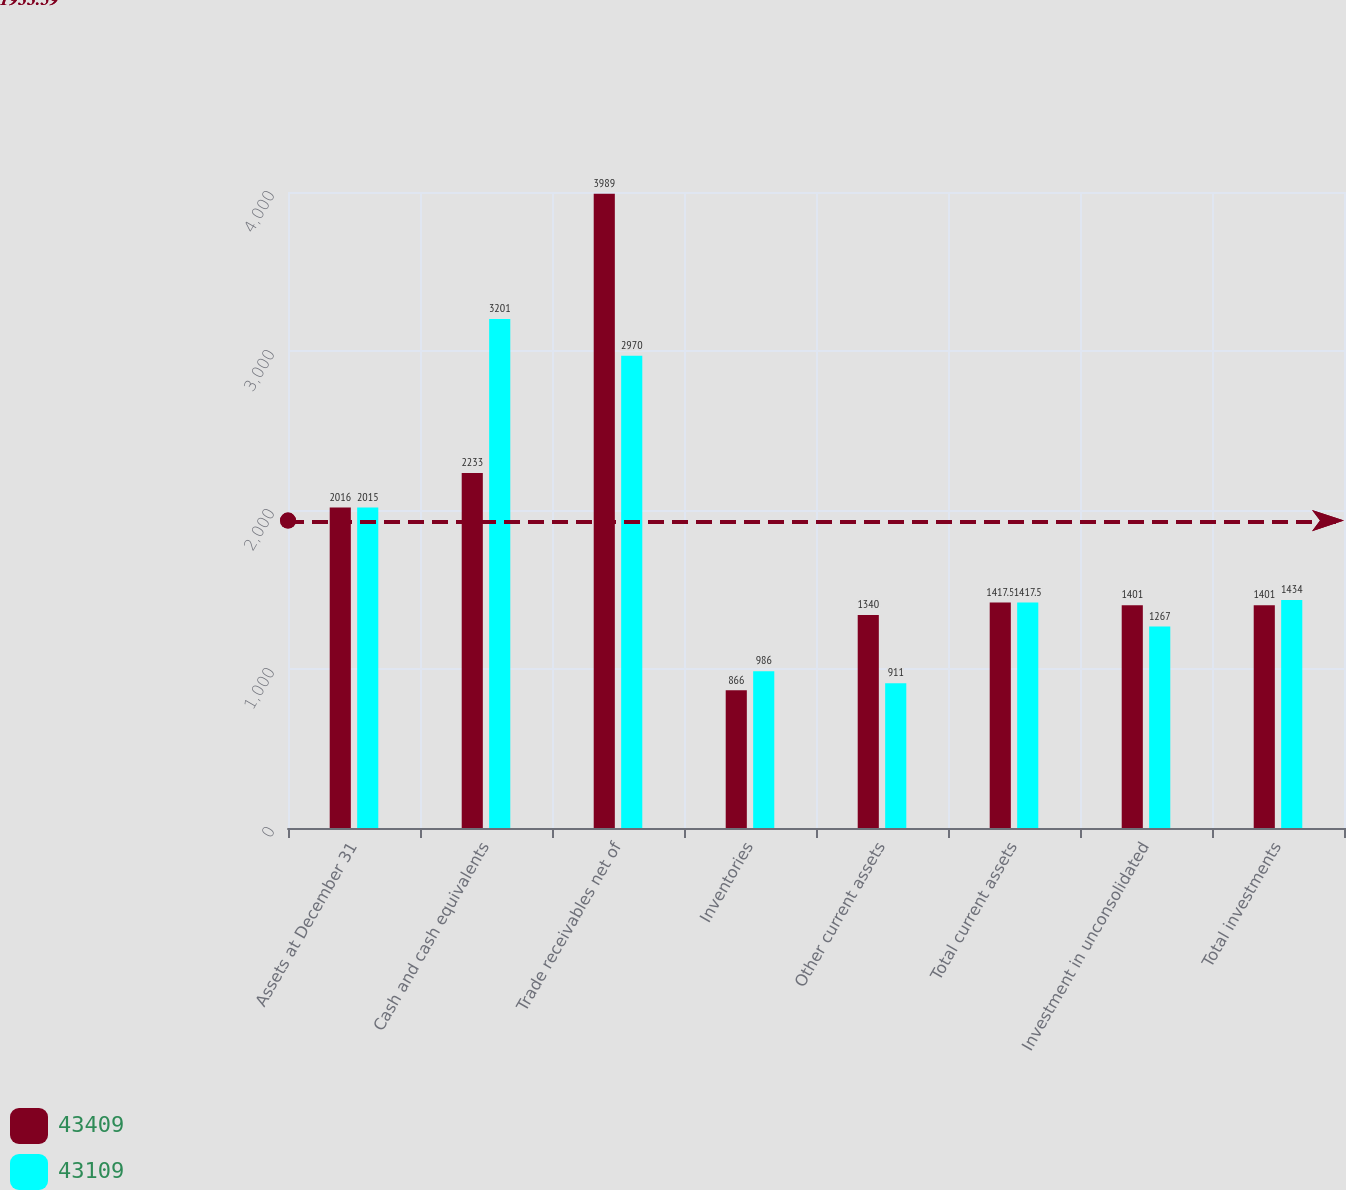<chart> <loc_0><loc_0><loc_500><loc_500><stacked_bar_chart><ecel><fcel>Assets at December 31<fcel>Cash and cash equivalents<fcel>Trade receivables net of<fcel>Inventories<fcel>Other current assets<fcel>Total current assets<fcel>Investment in unconsolidated<fcel>Total investments<nl><fcel>43409<fcel>2016<fcel>2233<fcel>3989<fcel>866<fcel>1340<fcel>1417.5<fcel>1401<fcel>1401<nl><fcel>43109<fcel>2015<fcel>3201<fcel>2970<fcel>986<fcel>911<fcel>1417.5<fcel>1267<fcel>1434<nl></chart> 